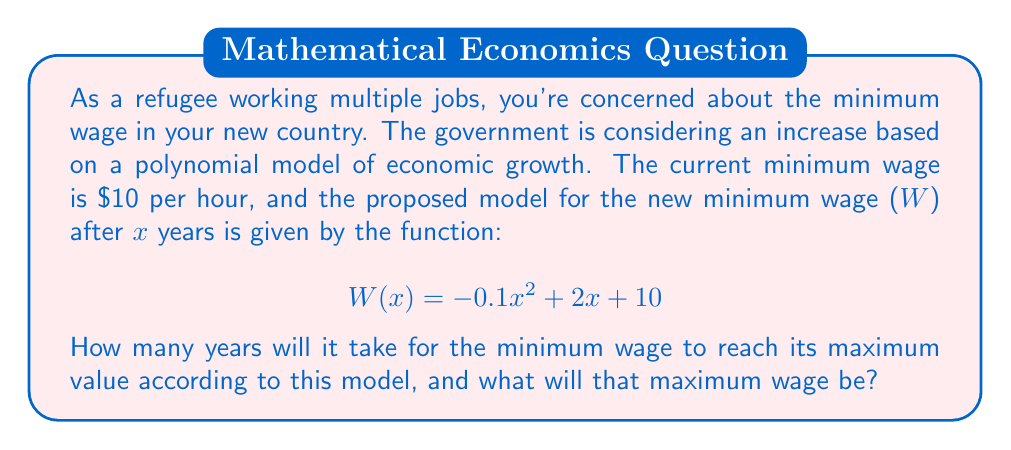Solve this math problem. To solve this problem, we'll follow these steps:

1) The given polynomial function is quadratic, with a negative leading coefficient. This means it will have a maximum value.

2) To find the maximum value, we need to find the vertex of the parabola. For a quadratic function in the form $f(x) = ax^2 + bx + c$, the x-coordinate of the vertex is given by $x = -\frac{b}{2a}$.

3) In our case, $a = -0.1$, $b = 2$, and $c = 10$. Let's calculate the x-coordinate:

   $$x = -\frac{2}{2(-0.1)} = -\frac{2}{-0.2} = 10$$

4) This means the maximum wage will occur after 10 years.

5) To find the maximum wage, we substitute x = 10 into the original function:

   $$W(10) = -0.1(10)^2 + 2(10) + 10$$
   $$= -0.1(100) + 20 + 10$$
   $$= -10 + 20 + 10$$
   $$= 20$$

Therefore, the maximum wage will be $20 per hour, reached after 10 years.
Answer: 10 years; $20 per hour 